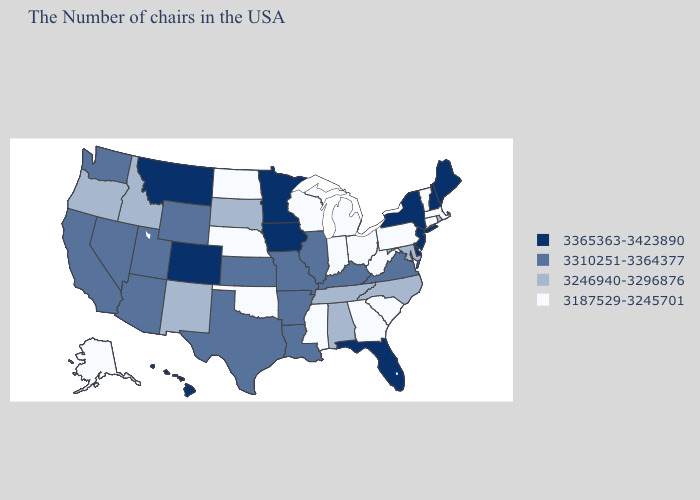Which states hav the highest value in the MidWest?
Write a very short answer. Minnesota, Iowa. What is the lowest value in the South?
Be succinct. 3187529-3245701. Name the states that have a value in the range 3246940-3296876?
Concise answer only. Rhode Island, Maryland, North Carolina, Alabama, Tennessee, South Dakota, New Mexico, Idaho, Oregon. Name the states that have a value in the range 3365363-3423890?
Answer briefly. Maine, New Hampshire, New York, New Jersey, Delaware, Florida, Minnesota, Iowa, Colorado, Montana, Hawaii. Among the states that border South Carolina , which have the highest value?
Short answer required. North Carolina. Name the states that have a value in the range 3365363-3423890?
Be succinct. Maine, New Hampshire, New York, New Jersey, Delaware, Florida, Minnesota, Iowa, Colorado, Montana, Hawaii. Does Nevada have a lower value than Iowa?
Be succinct. Yes. Does Iowa have the lowest value in the USA?
Be succinct. No. What is the value of Arkansas?
Give a very brief answer. 3310251-3364377. Name the states that have a value in the range 3187529-3245701?
Keep it brief. Massachusetts, Vermont, Connecticut, Pennsylvania, South Carolina, West Virginia, Ohio, Georgia, Michigan, Indiana, Wisconsin, Mississippi, Nebraska, Oklahoma, North Dakota, Alaska. Does the map have missing data?
Write a very short answer. No. Does West Virginia have a higher value than Pennsylvania?
Short answer required. No. What is the highest value in the Northeast ?
Write a very short answer. 3365363-3423890. Name the states that have a value in the range 3365363-3423890?
Keep it brief. Maine, New Hampshire, New York, New Jersey, Delaware, Florida, Minnesota, Iowa, Colorado, Montana, Hawaii. Name the states that have a value in the range 3310251-3364377?
Quick response, please. Virginia, Kentucky, Illinois, Louisiana, Missouri, Arkansas, Kansas, Texas, Wyoming, Utah, Arizona, Nevada, California, Washington. 